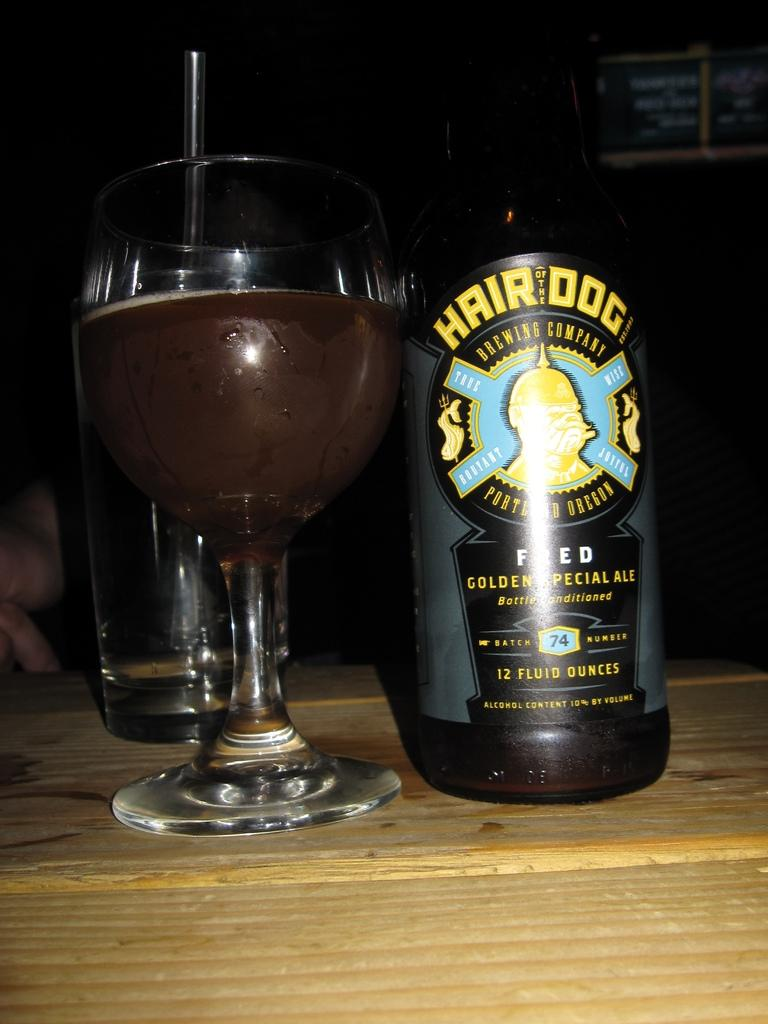Provide a one-sentence caption for the provided image. A bottle of Hair of the Dog beer on a table next to a glass. 